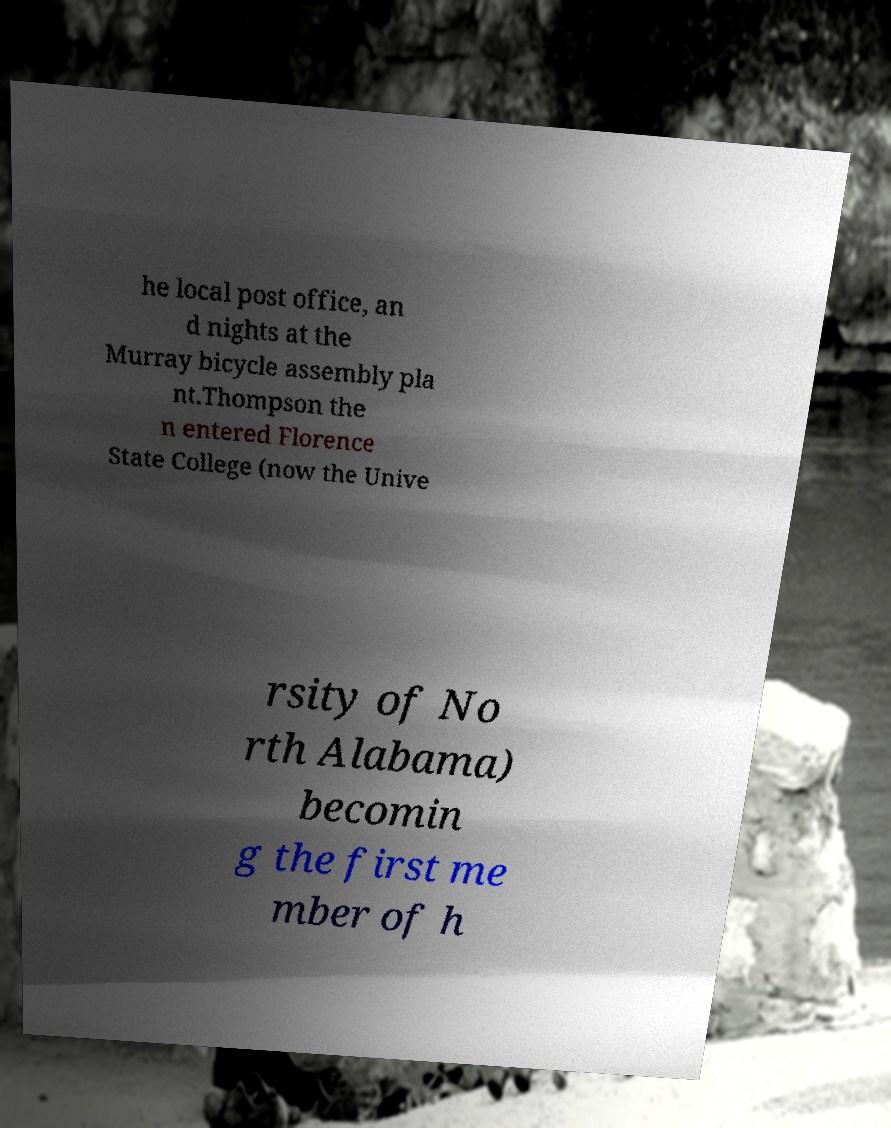Can you read and provide the text displayed in the image?This photo seems to have some interesting text. Can you extract and type it out for me? he local post office, an d nights at the Murray bicycle assembly pla nt.Thompson the n entered Florence State College (now the Unive rsity of No rth Alabama) becomin g the first me mber of h 